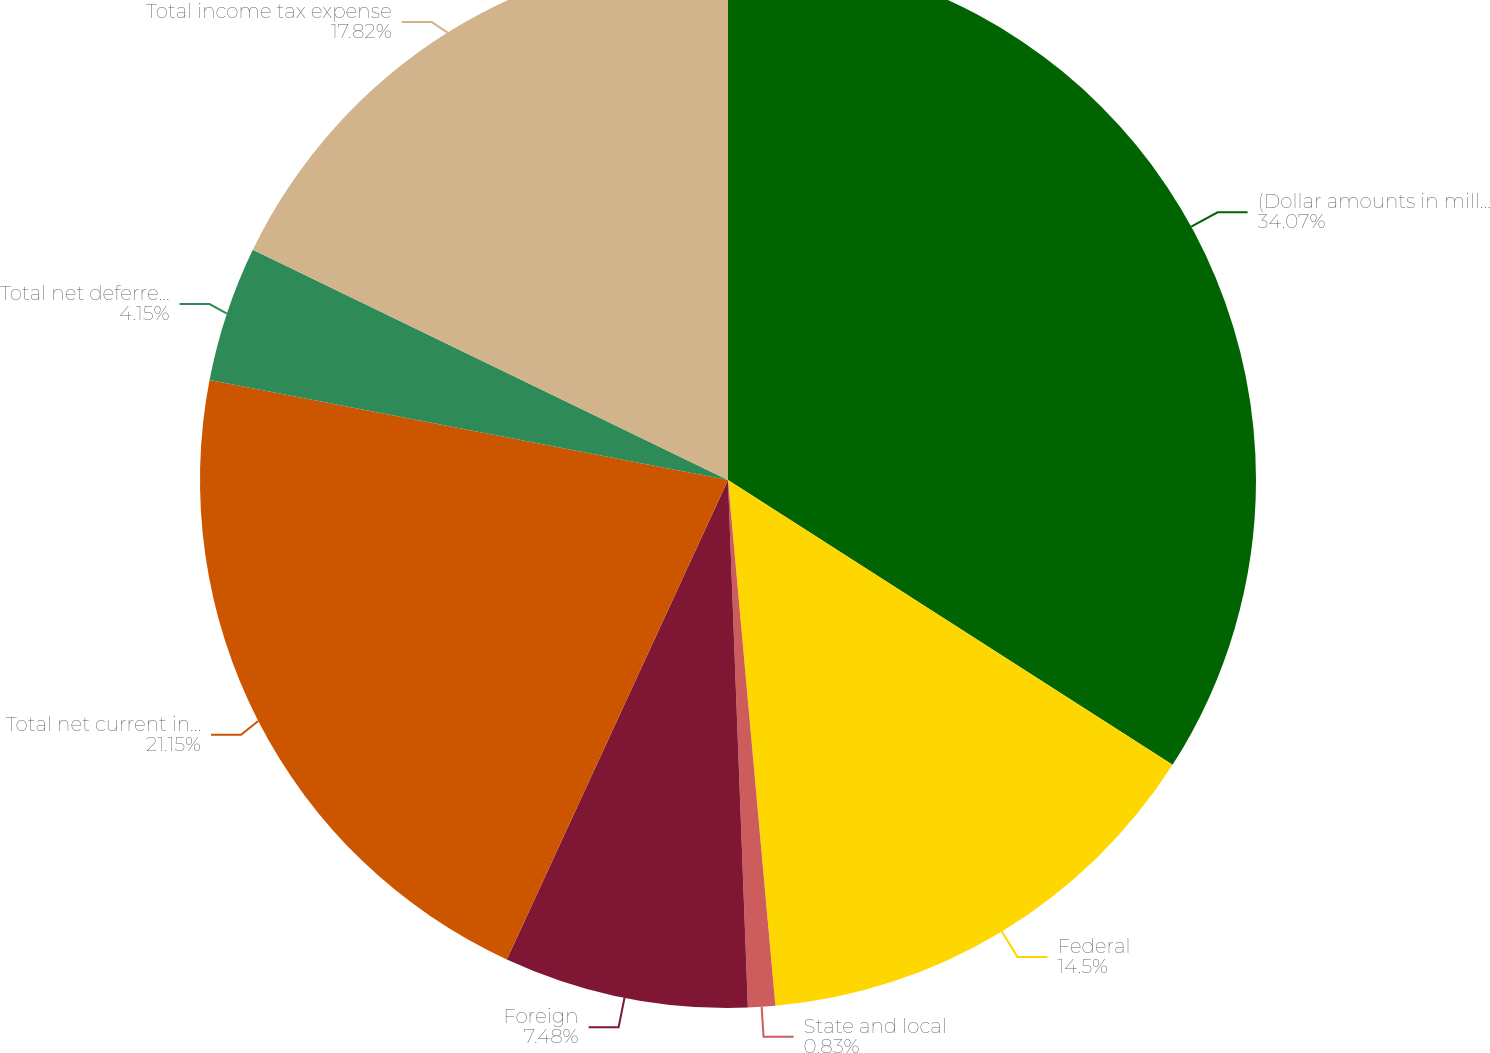<chart> <loc_0><loc_0><loc_500><loc_500><pie_chart><fcel>(Dollar amounts in millions)<fcel>Federal<fcel>State and local<fcel>Foreign<fcel>Total net current income tax<fcel>Total net deferred income tax<fcel>Total income tax expense<nl><fcel>34.07%<fcel>14.5%<fcel>0.83%<fcel>7.48%<fcel>21.15%<fcel>4.15%<fcel>17.82%<nl></chart> 